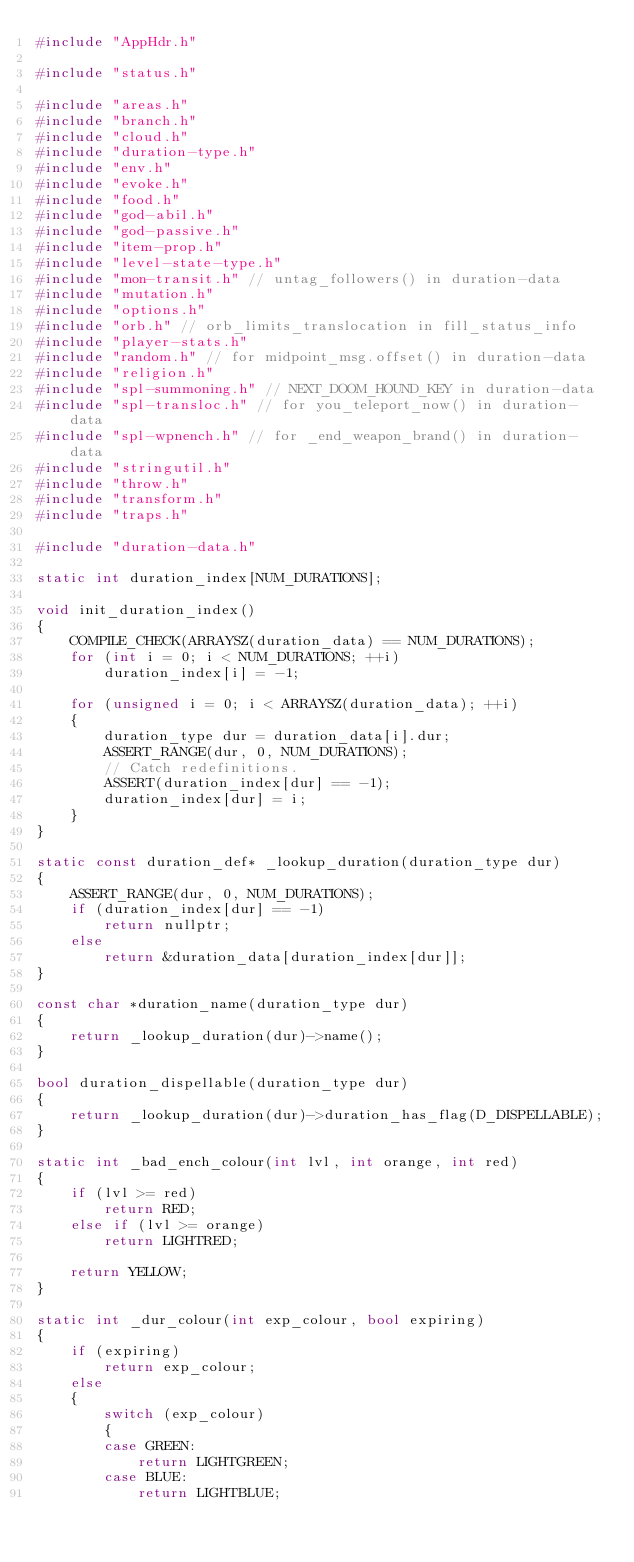Convert code to text. <code><loc_0><loc_0><loc_500><loc_500><_C++_>#include "AppHdr.h"

#include "status.h"

#include "areas.h"
#include "branch.h"
#include "cloud.h"
#include "duration-type.h"
#include "env.h"
#include "evoke.h"
#include "food.h"
#include "god-abil.h"
#include "god-passive.h"
#include "item-prop.h"
#include "level-state-type.h"
#include "mon-transit.h" // untag_followers() in duration-data
#include "mutation.h"
#include "options.h"
#include "orb.h" // orb_limits_translocation in fill_status_info
#include "player-stats.h"
#include "random.h" // for midpoint_msg.offset() in duration-data
#include "religion.h"
#include "spl-summoning.h" // NEXT_DOOM_HOUND_KEY in duration-data
#include "spl-transloc.h" // for you_teleport_now() in duration-data
#include "spl-wpnench.h" // for _end_weapon_brand() in duration-data
#include "stringutil.h"
#include "throw.h"
#include "transform.h"
#include "traps.h"

#include "duration-data.h"

static int duration_index[NUM_DURATIONS];

void init_duration_index()
{
    COMPILE_CHECK(ARRAYSZ(duration_data) == NUM_DURATIONS);
    for (int i = 0; i < NUM_DURATIONS; ++i)
        duration_index[i] = -1;

    for (unsigned i = 0; i < ARRAYSZ(duration_data); ++i)
    {
        duration_type dur = duration_data[i].dur;
        ASSERT_RANGE(dur, 0, NUM_DURATIONS);
        // Catch redefinitions.
        ASSERT(duration_index[dur] == -1);
        duration_index[dur] = i;
    }
}

static const duration_def* _lookup_duration(duration_type dur)
{
    ASSERT_RANGE(dur, 0, NUM_DURATIONS);
    if (duration_index[dur] == -1)
        return nullptr;
    else
        return &duration_data[duration_index[dur]];
}

const char *duration_name(duration_type dur)
{
    return _lookup_duration(dur)->name();
}

bool duration_dispellable(duration_type dur)
{
    return _lookup_duration(dur)->duration_has_flag(D_DISPELLABLE);
}

static int _bad_ench_colour(int lvl, int orange, int red)
{
    if (lvl >= red)
        return RED;
    else if (lvl >= orange)
        return LIGHTRED;

    return YELLOW;
}

static int _dur_colour(int exp_colour, bool expiring)
{
    if (expiring)
        return exp_colour;
    else
    {
        switch (exp_colour)
        {
        case GREEN:
            return LIGHTGREEN;
        case BLUE:
            return LIGHTBLUE;</code> 